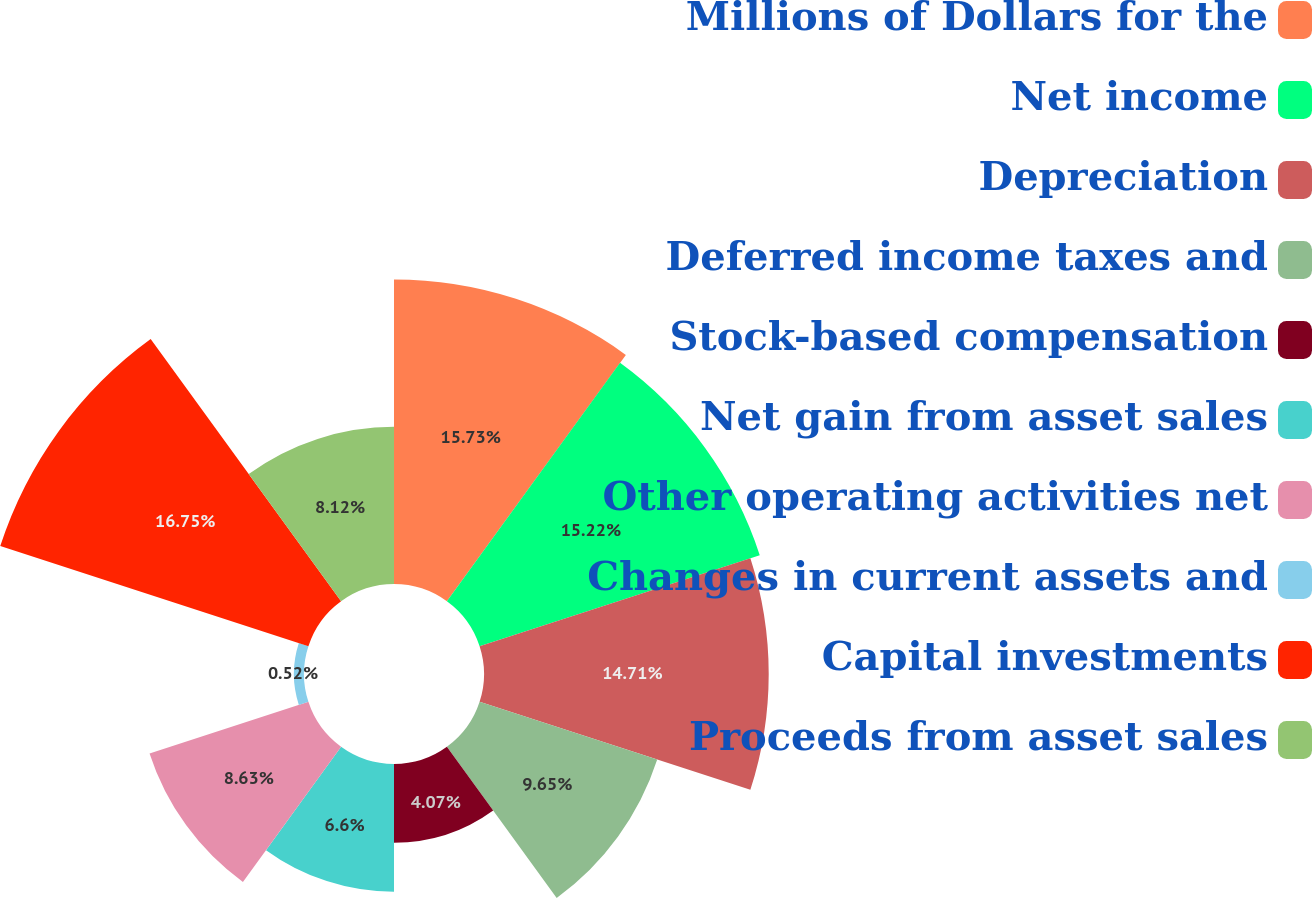Convert chart to OTSL. <chart><loc_0><loc_0><loc_500><loc_500><pie_chart><fcel>Millions of Dollars for the<fcel>Net income<fcel>Depreciation<fcel>Deferred income taxes and<fcel>Stock-based compensation<fcel>Net gain from asset sales<fcel>Other operating activities net<fcel>Changes in current assets and<fcel>Capital investments<fcel>Proceeds from asset sales<nl><fcel>15.73%<fcel>15.22%<fcel>14.71%<fcel>9.65%<fcel>4.07%<fcel>6.6%<fcel>8.63%<fcel>0.52%<fcel>16.74%<fcel>8.12%<nl></chart> 